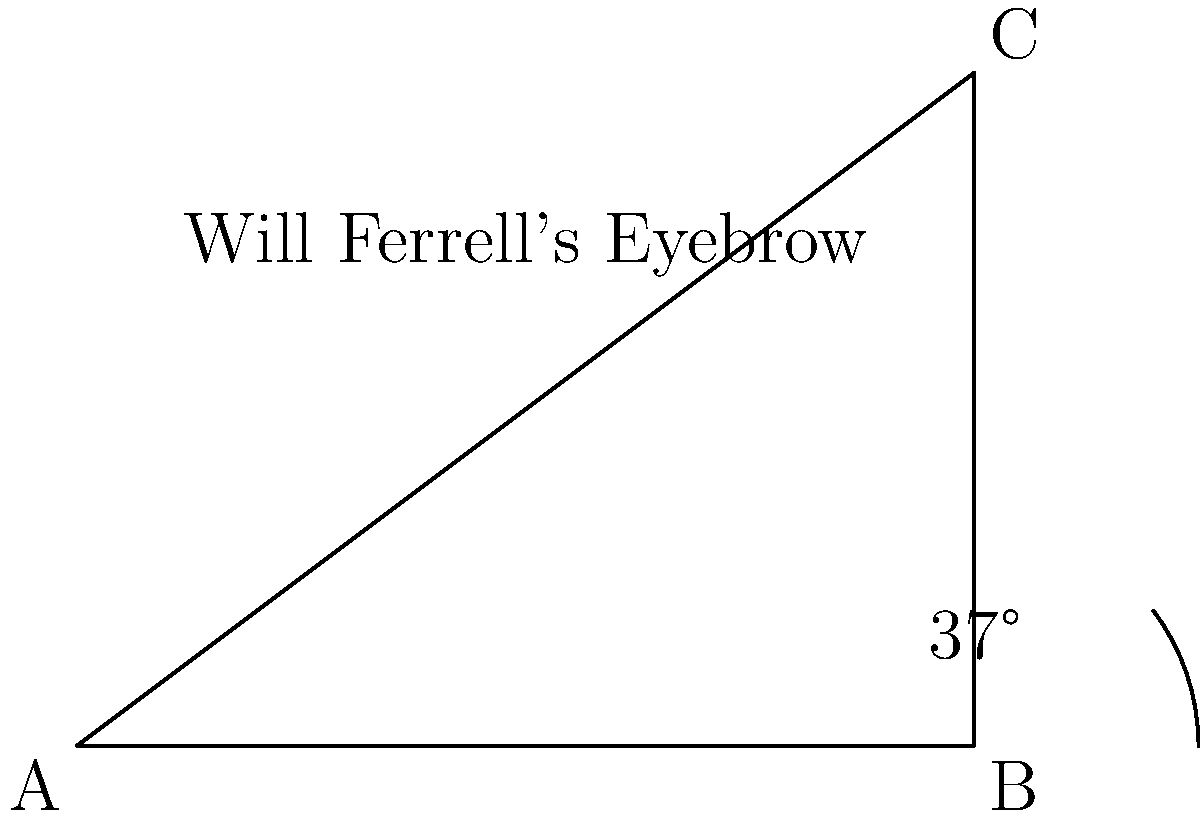In a famous scene, Will Ferrell's iconic arched eyebrow forms a right triangle. If the angle at the base of his eyebrow is 37°, what is the measure of the angle at the peak of his eyebrow? To find the angle at the peak of Will Ferrell's eyebrow, we can use the properties of right triangles:

1. In a right triangle, the sum of all angles is 180°.
2. We know one angle is 90° (the right angle).
3. We're given that the angle at the base of the eyebrow is 37°.

Let's solve step-by-step:

1. Let x be the unknown angle at the peak of the eyebrow.
2. Set up the equation: $90° + 37° + x = 180°$
3. Simplify: $127° + x = 180°$
4. Subtract 127° from both sides: $x = 180° - 127°$
5. Solve: $x = 53°$

Therefore, the angle at the peak of Will Ferrell's eyebrow is 53°.
Answer: 53° 